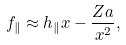Convert formula to latex. <formula><loc_0><loc_0><loc_500><loc_500>f _ { \| } \approx h _ { \| } x - \frac { Z a } { x ^ { 2 } } ,</formula> 